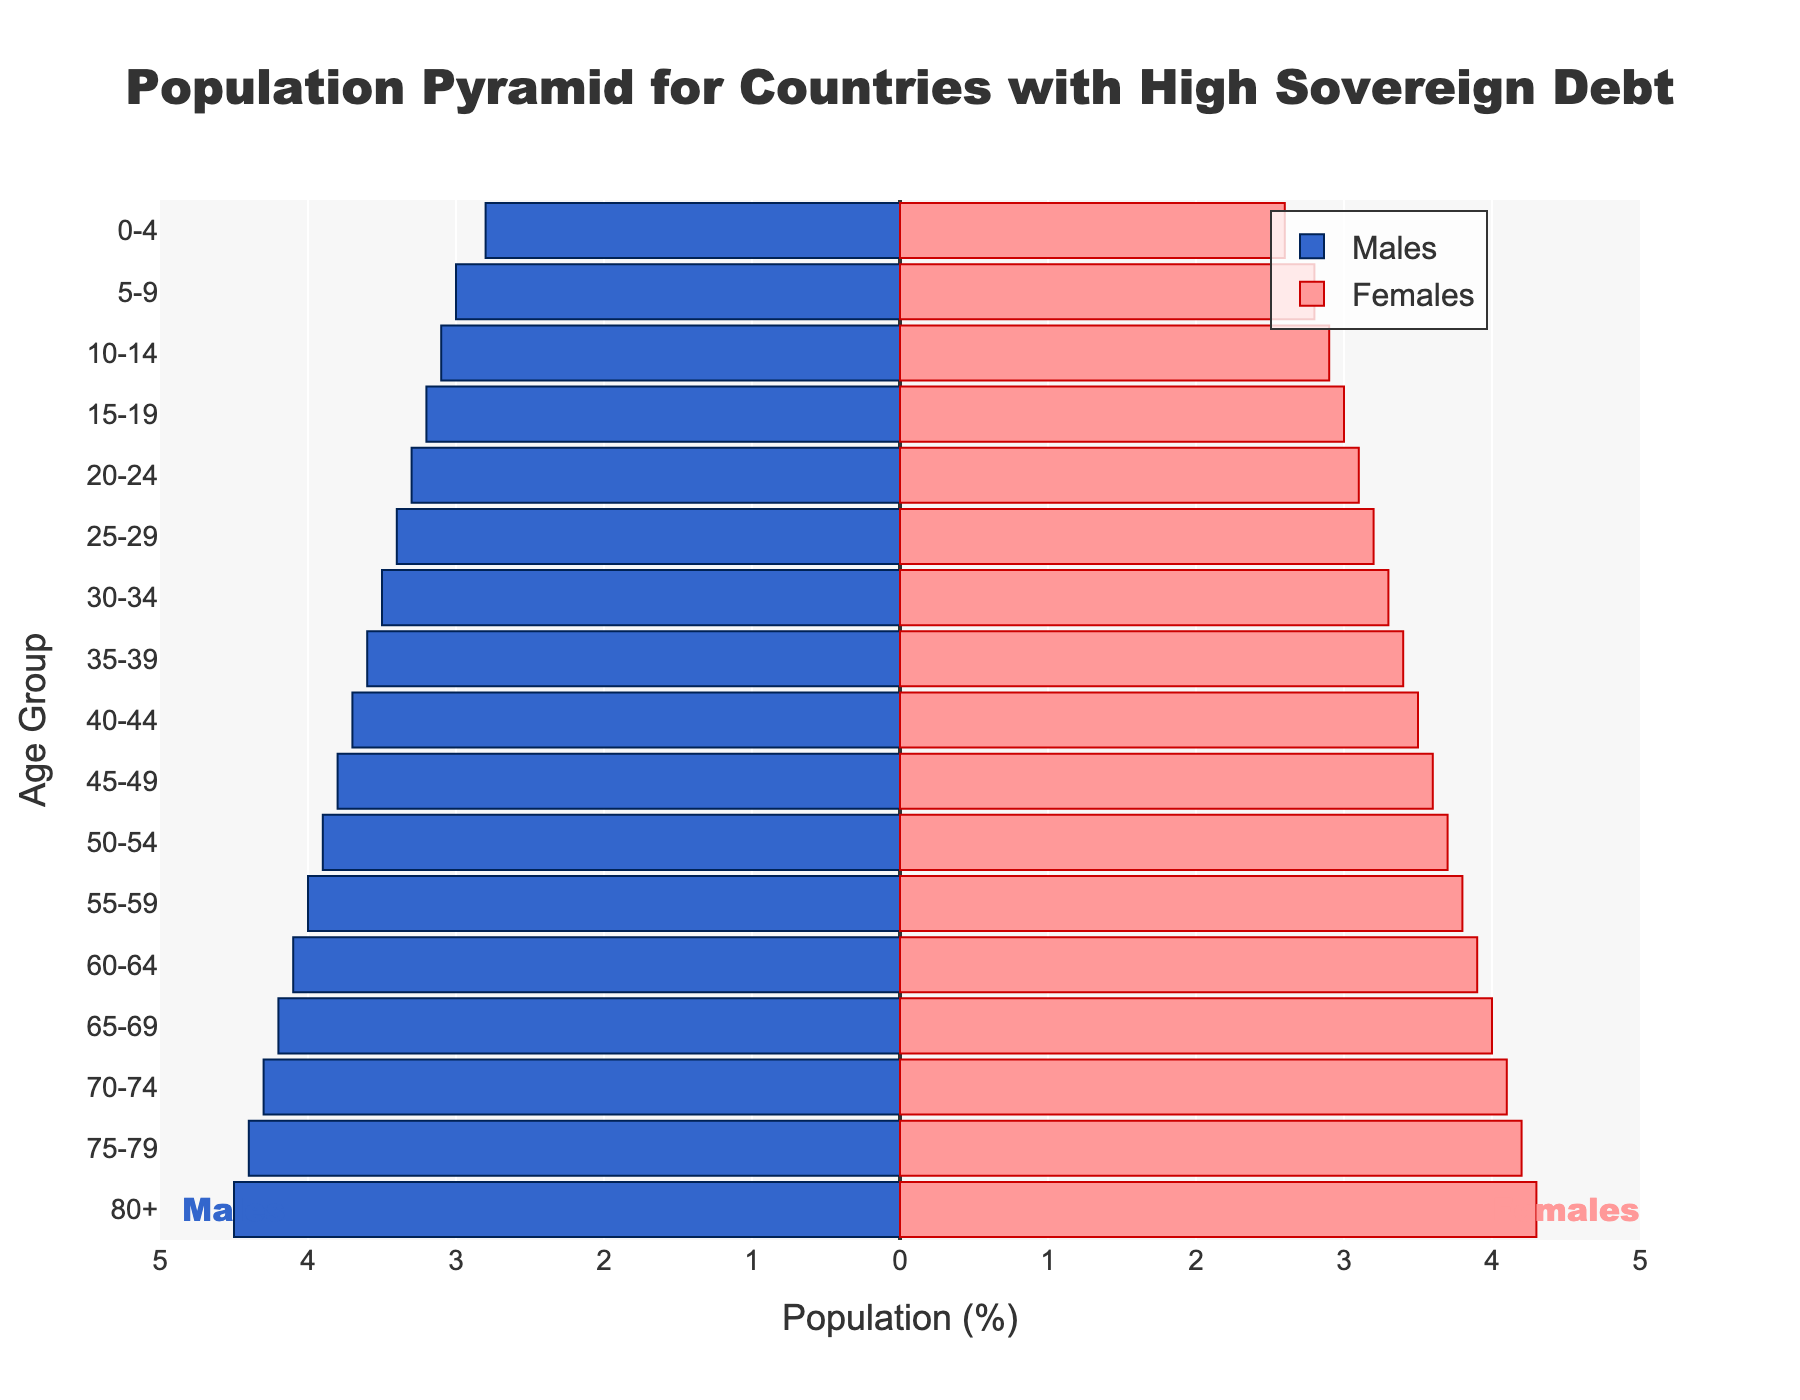what is the population percentage for males in the age group 30-34? Look at the bar for males in the age group 30-34, which is -3.5% (indicating 3.5% as we use negative for males)
Answer: 3.5% What is the percentage difference between males and females in the 0-4 age group? The percentage of males in the 0-4 age group is 2.8%, and for females, it is 2.6%. Subtract 2.6 from 2.8 to find the difference, which is 0.2%
Answer: 0.2% Which age group has the highest percentage of females? Look for the bar with the highest percentage in the female section. The highest value is 4.3% for the age group 80+
Answer: 80+ Are there any age groups with the same percentage for both males and females? If so, which? Compare the percentages of males and females in each age group. There are no age groups with equal percentages in both genders
Answer: No What trend can you observe in the percentage distribution as age increases? Observing the bars, the percentage for both males and females generally increases as age increases, peaking at the 80+ group
Answer: Increases with age Which gender has a higher percentage in the age group 55-59? Compare the bar lengths for males and females in the age group 55-59. Males have 4.0% and females have 3.8%. Males have a higher percentage
Answer: Males When combining both genders, which age group has the highest total population percentage? Add the percentages of males and females for each age group. The age group 80+ has the highest total (4.5% males + 4.3% females = 8.8%)
Answer: 80+ Is the percentage difference between males and females in the 70-74 age group more or less than 0.5%? The percentage for males is 4.3% and for females, it's 4.1%. The difference is 0.2%, which is less than 0.5%
Answer: Less What is the percentage increase of populations from the 20-24 age group to the 30-34 age group for males? The percentage for males in the 20-24 age group is 3.3%, and in the 30-34 age group, it is 3.5%. Subtract 3.3 from 3.5, which gives us 0.2%
Answer: 0.2% How does the size of the male population compare to the female population in the age group 45-49? The percentage of males in the 45-49 age group is 3.8%, and for females, it is 3.6%. The male percentage is slightly higher
Answer: Males higher 